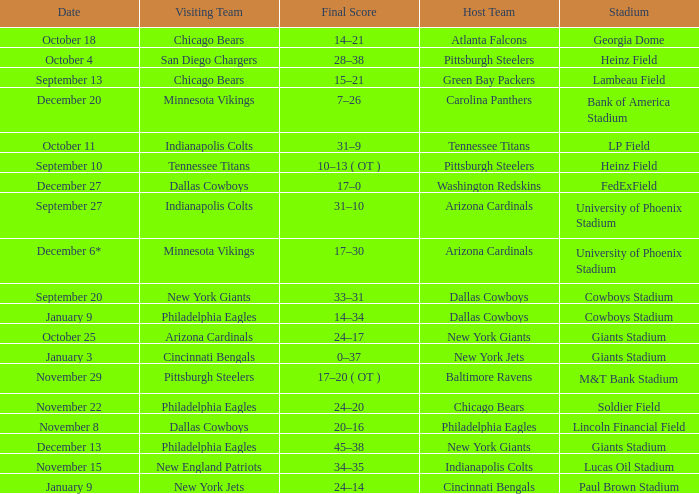Tell me the visiting team for october 4 San Diego Chargers. 